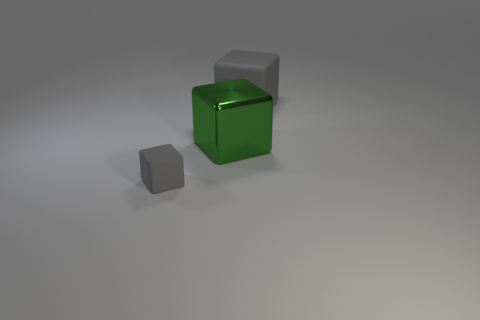Add 1 small gray rubber cubes. How many objects exist? 4 Subtract 0 yellow balls. How many objects are left? 3 Subtract all large gray blocks. Subtract all small gray matte cubes. How many objects are left? 1 Add 1 big gray blocks. How many big gray blocks are left? 2 Add 2 tiny purple metallic cubes. How many tiny purple metallic cubes exist? 2 